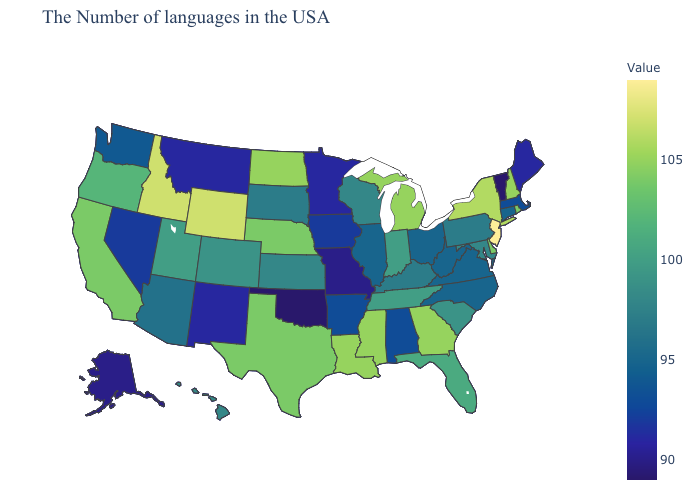Which states have the lowest value in the USA?
Short answer required. Vermont, Oklahoma. Does Arizona have the highest value in the West?
Short answer required. No. Among the states that border Kansas , which have the highest value?
Short answer required. Nebraska. Among the states that border Kansas , does Nebraska have the lowest value?
Answer briefly. No. Which states have the highest value in the USA?
Answer briefly. New Jersey. 